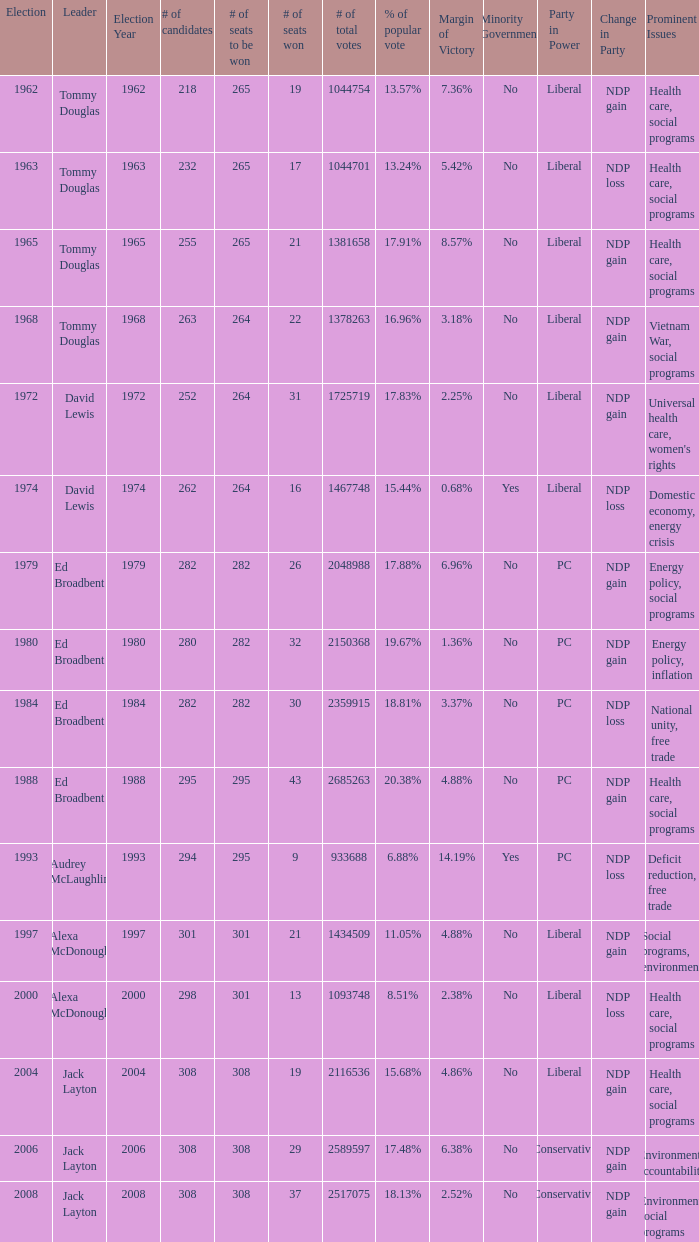Name the number of total votes for # of seats won being 30 2359915.0. 